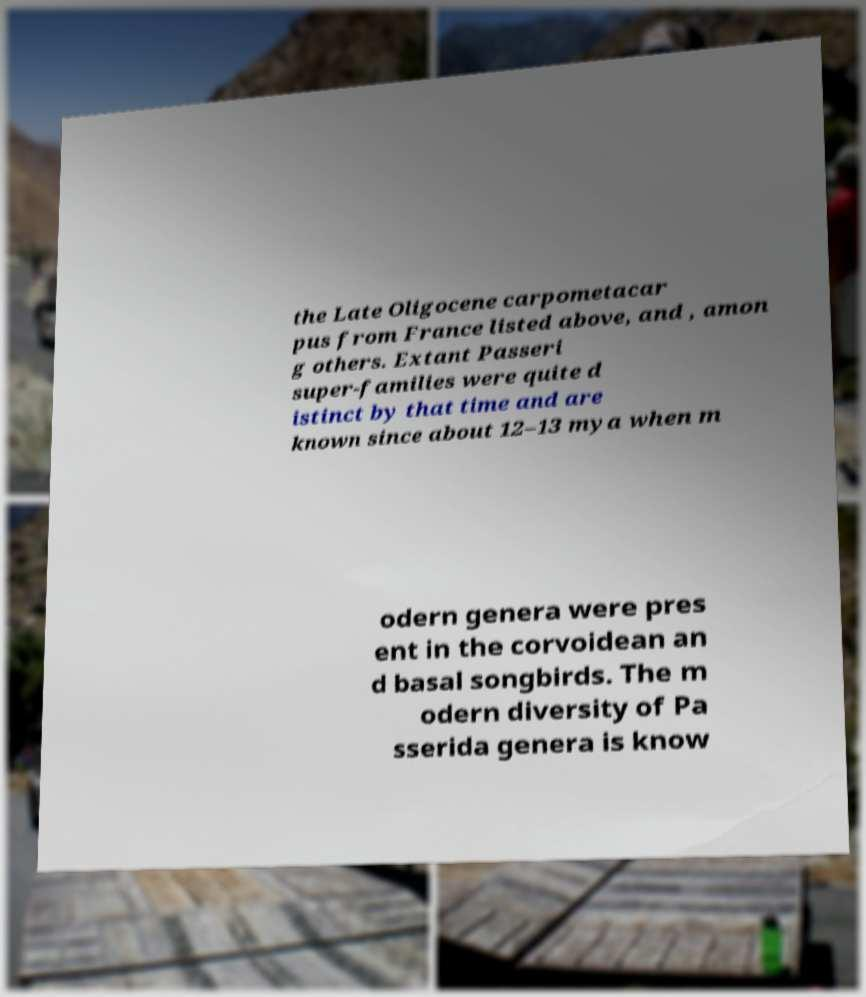Please read and relay the text visible in this image. What does it say? the Late Oligocene carpometacar pus from France listed above, and , amon g others. Extant Passeri super-families were quite d istinct by that time and are known since about 12–13 mya when m odern genera were pres ent in the corvoidean an d basal songbirds. The m odern diversity of Pa sserida genera is know 